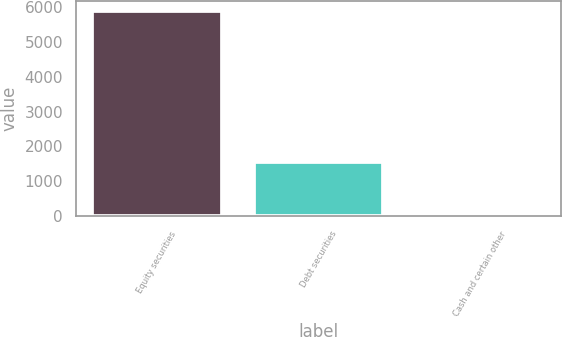Convert chart to OTSL. <chart><loc_0><loc_0><loc_500><loc_500><bar_chart><fcel>Equity securities<fcel>Debt securities<fcel>Cash and certain other<nl><fcel>5885<fcel>1542<fcel>5<nl></chart> 